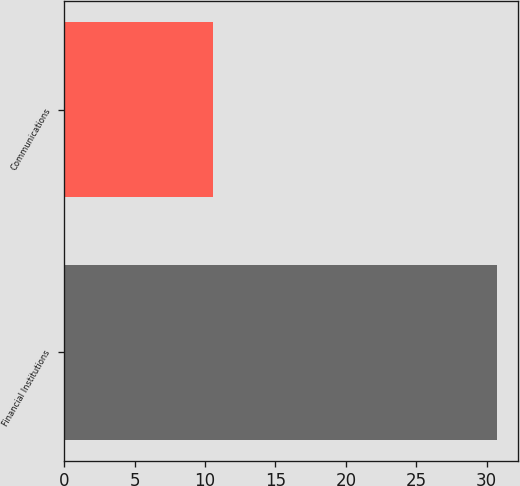Convert chart to OTSL. <chart><loc_0><loc_0><loc_500><loc_500><bar_chart><fcel>Financial Institutions<fcel>Communications<nl><fcel>30.7<fcel>10.6<nl></chart> 